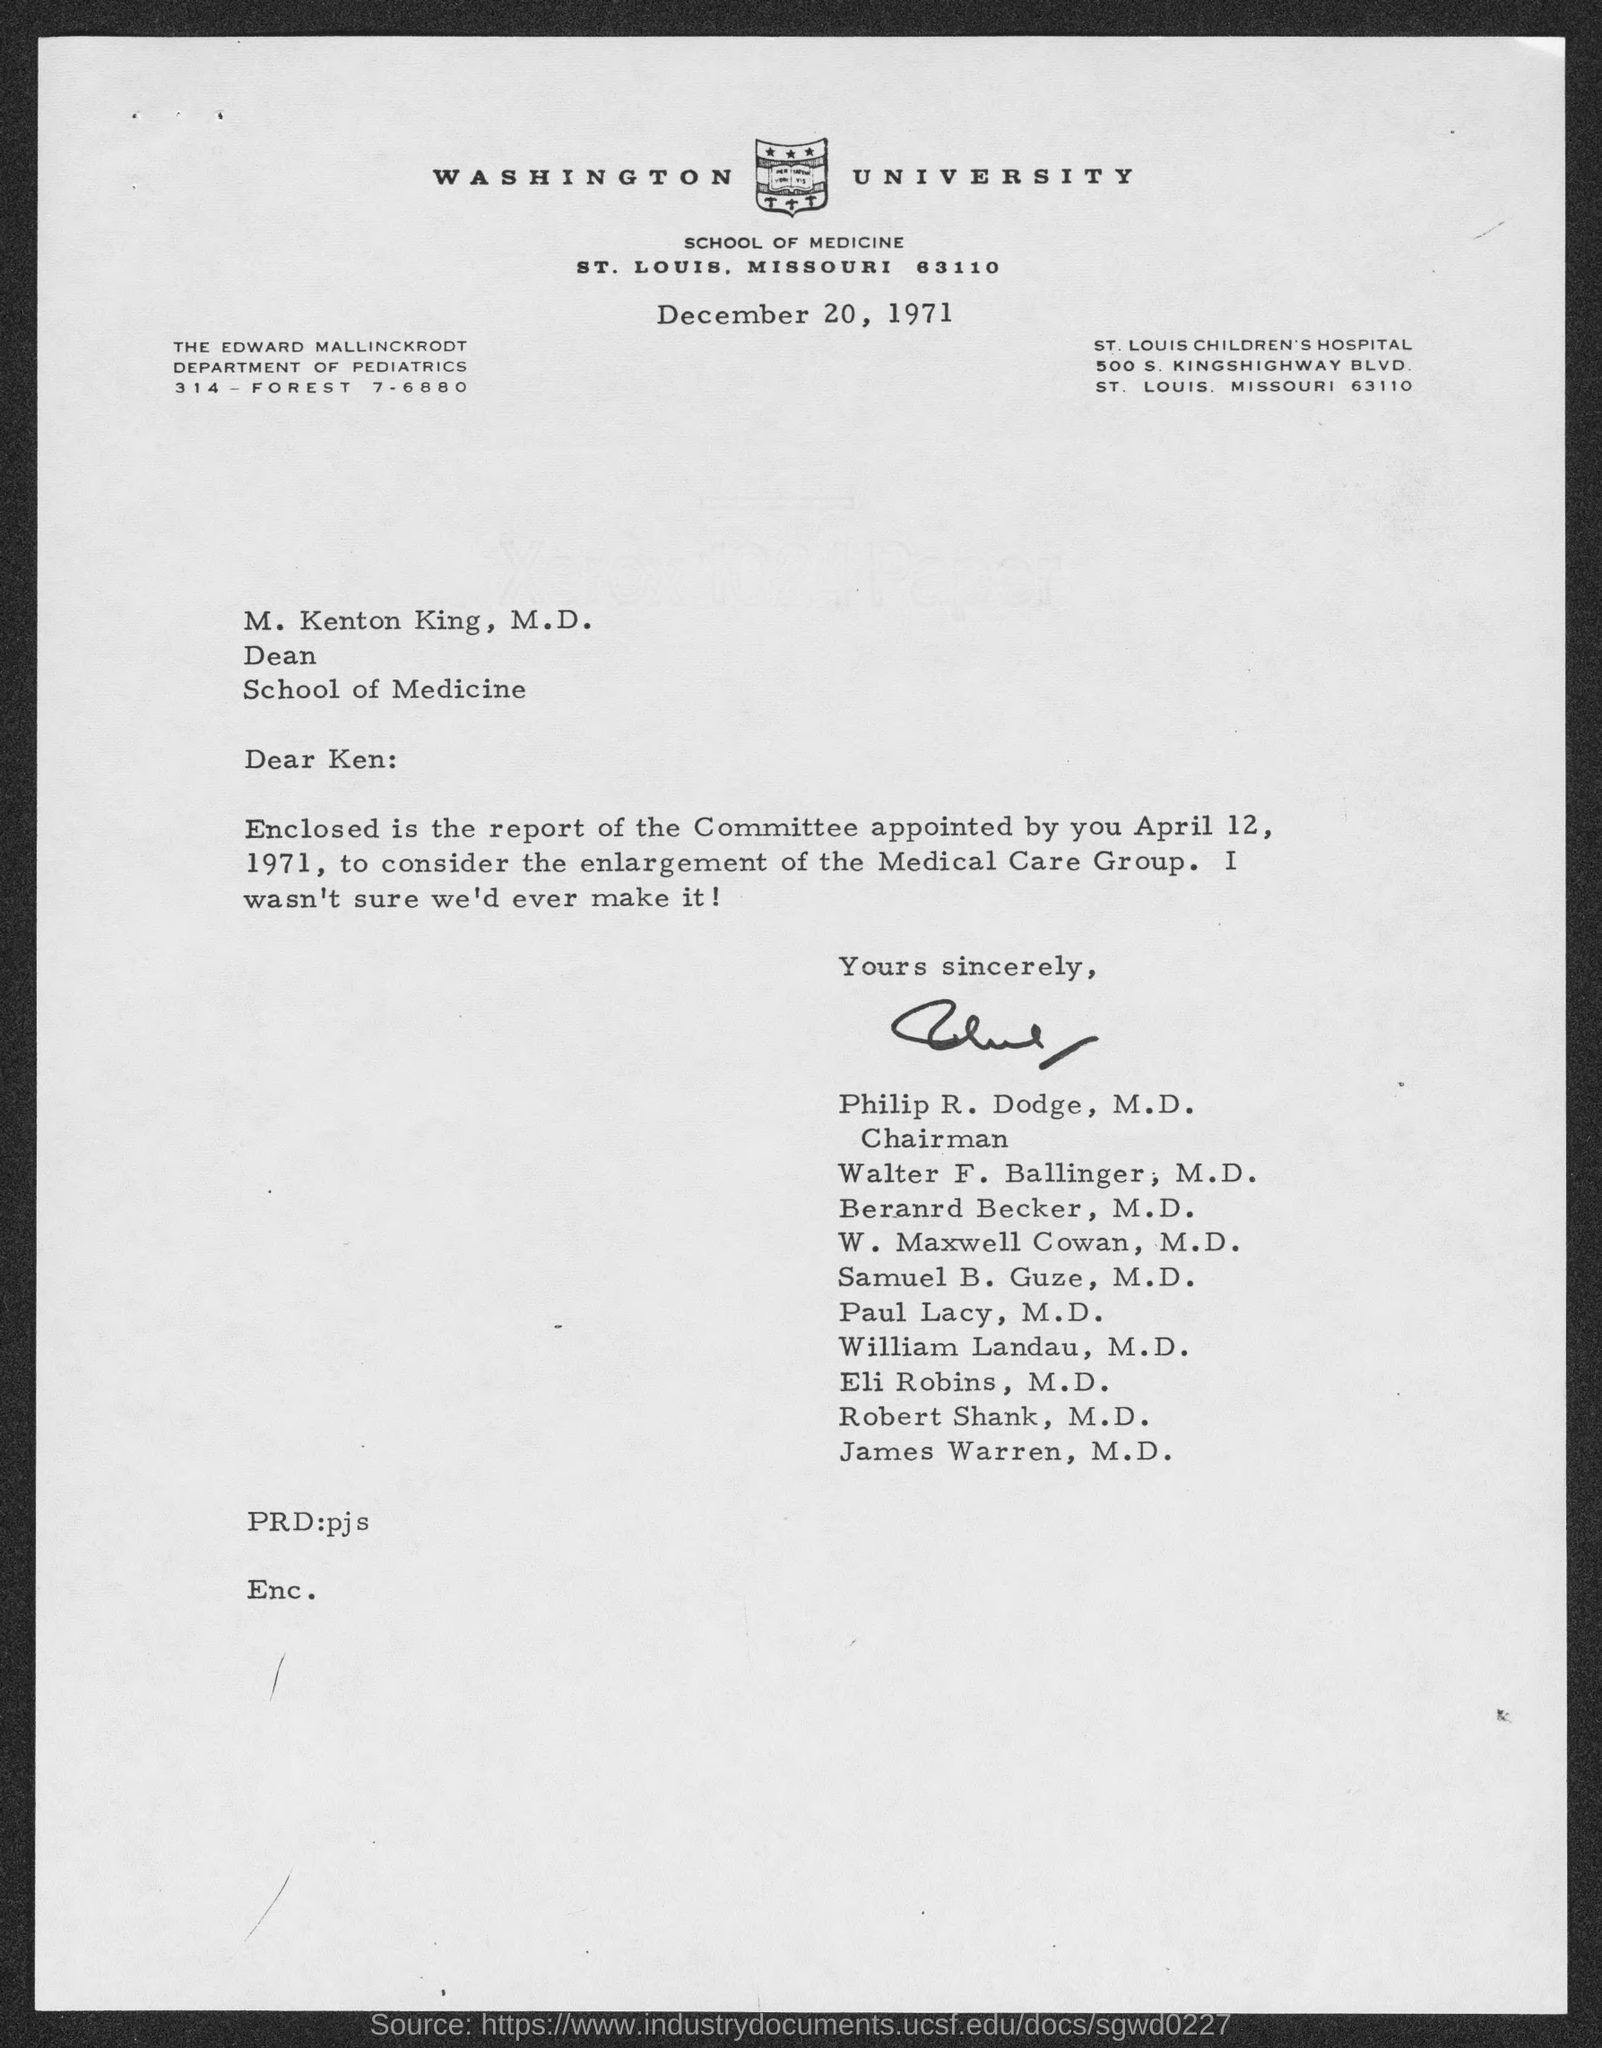When is the letter dated?
Provide a short and direct response. DECEMBER 20, 1971. 